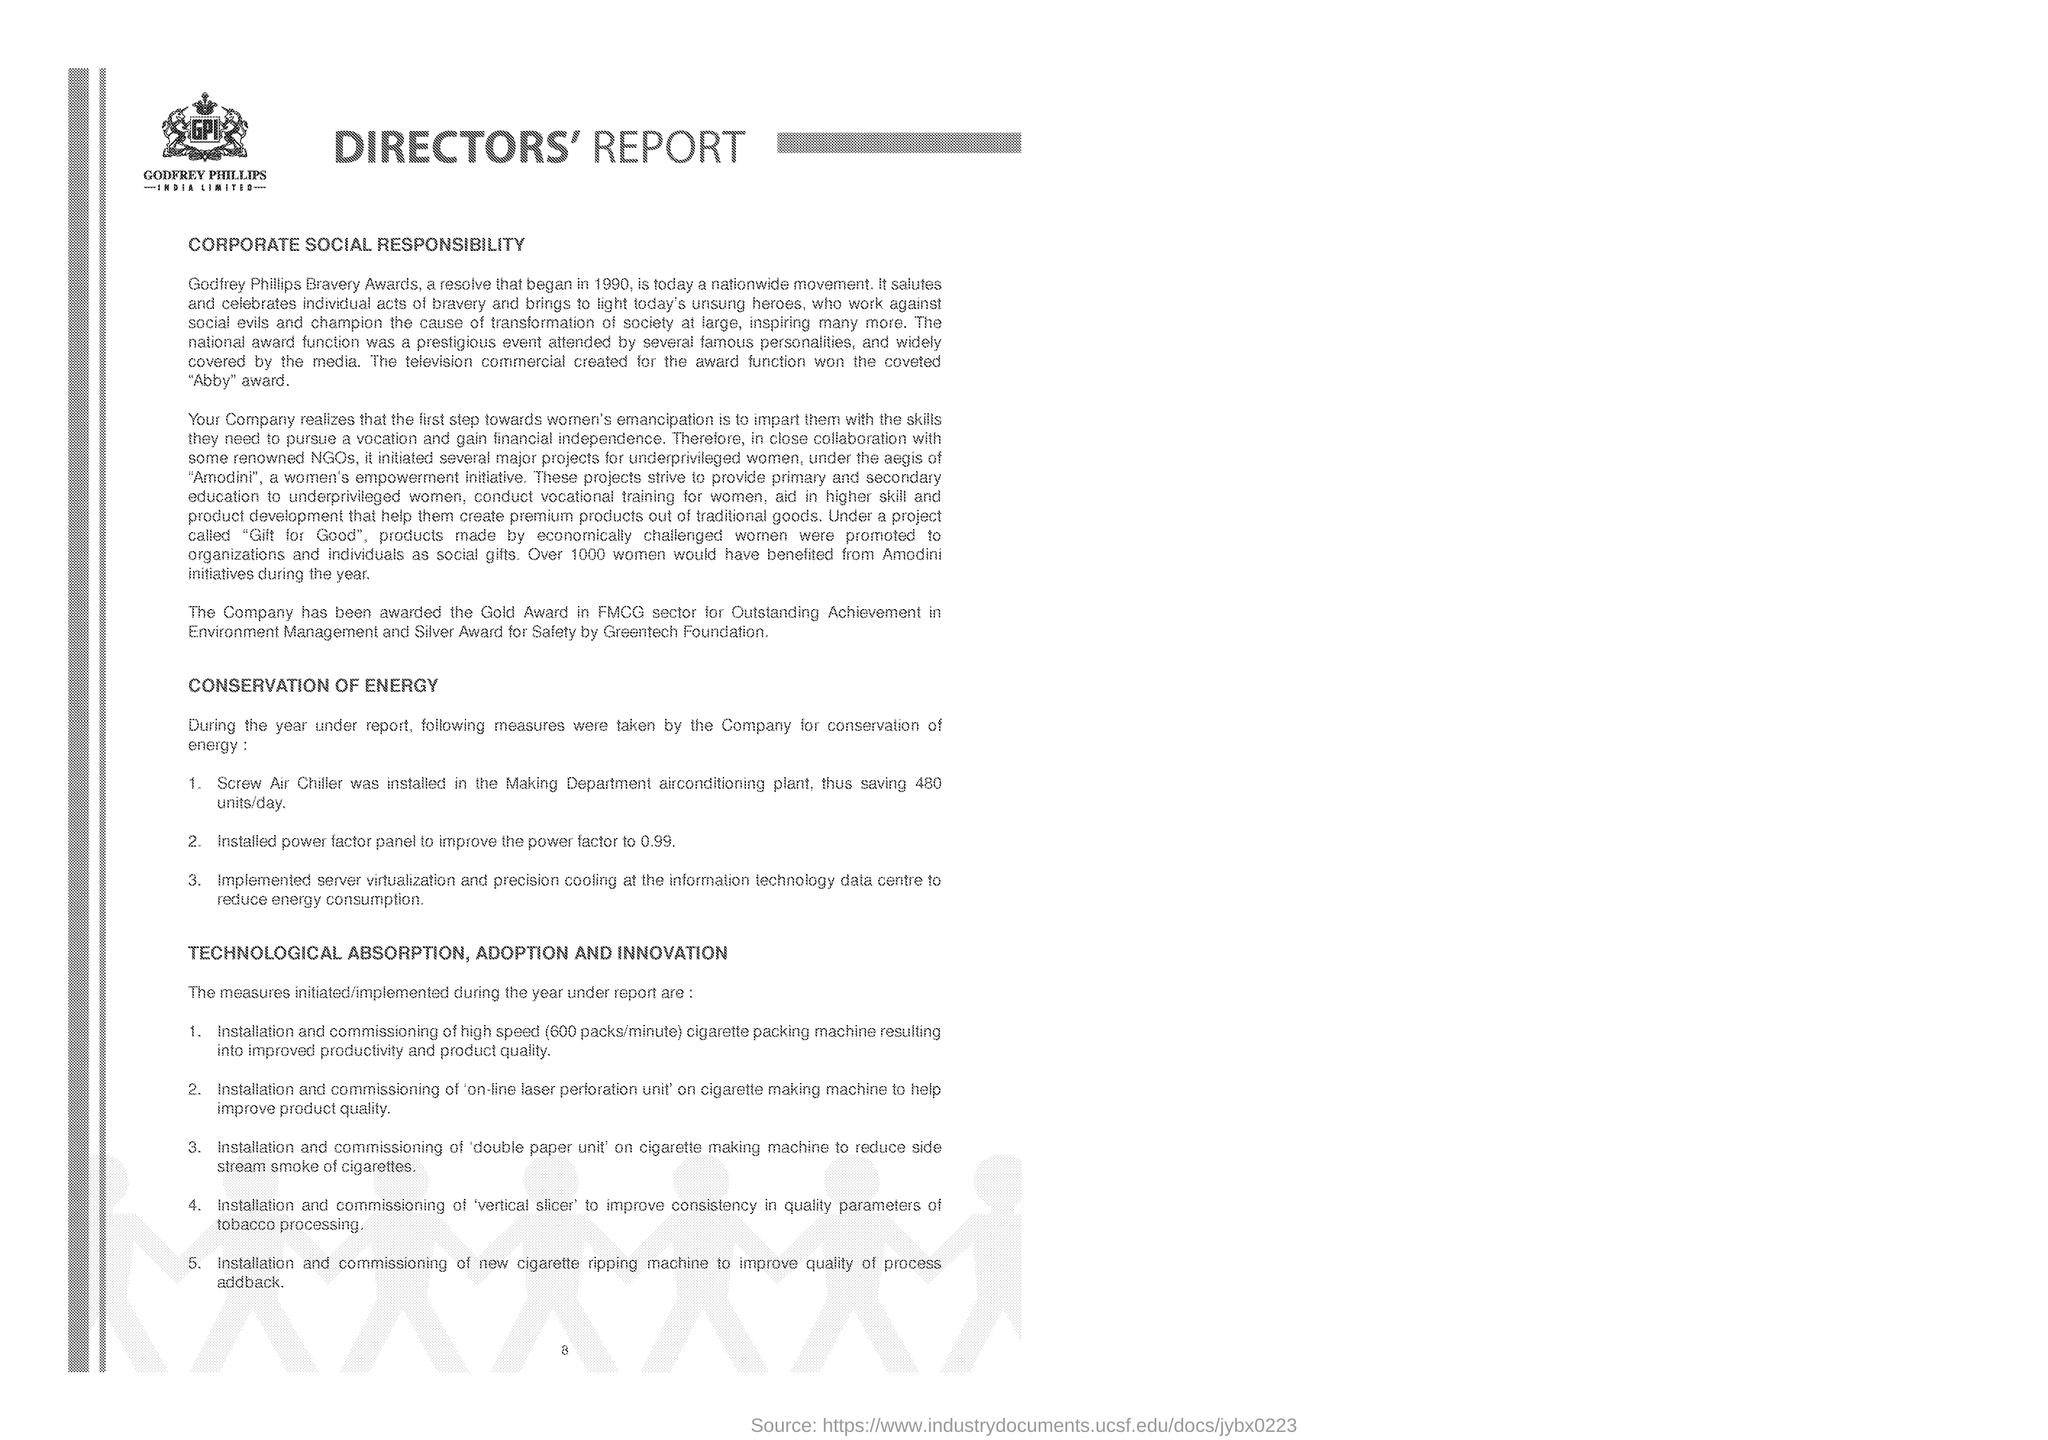Mention a couple of crucial points in this snapshot. The installation of the 'vertical slicer' is aimed at improving the consistency of quality parameters in the processing of tobacco. The company was awarded the Gold Award in the FMCG sector for outstanding achievement in environment management. The Godfrey Phillips Bravery Award began in the year 1990. Installing a Screw Air Chiller in the Making Department air conditioning plant could potentially save up to 480 units per day. Godfrey Phillips is the company that is featured in the logo. 